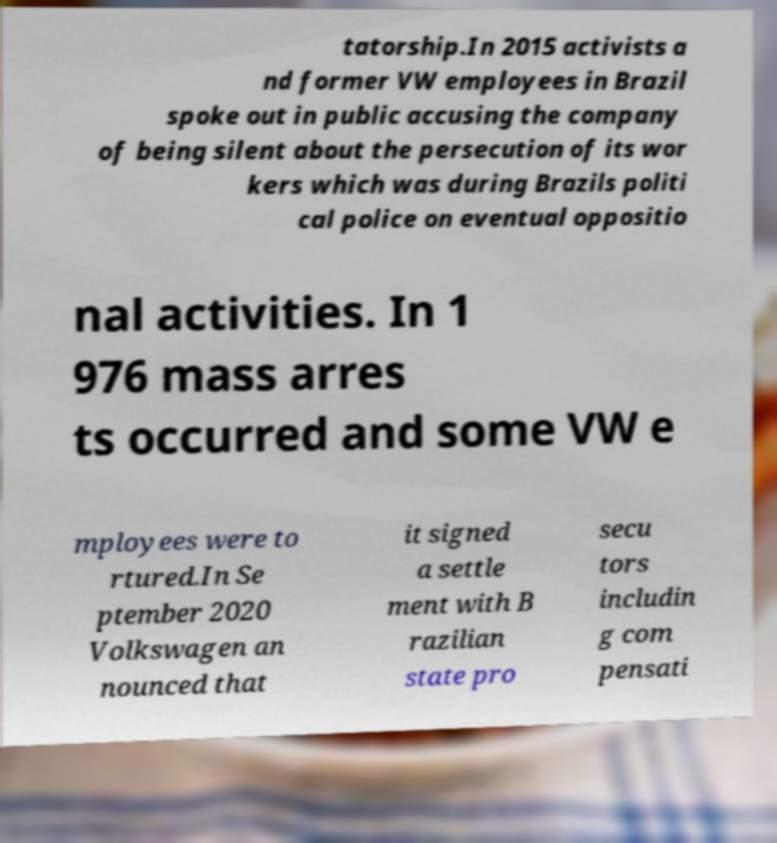Please read and relay the text visible in this image. What does it say? tatorship.In 2015 activists a nd former VW employees in Brazil spoke out in public accusing the company of being silent about the persecution of its wor kers which was during Brazils politi cal police on eventual oppositio nal activities. In 1 976 mass arres ts occurred and some VW e mployees were to rtured.In Se ptember 2020 Volkswagen an nounced that it signed a settle ment with B razilian state pro secu tors includin g com pensati 